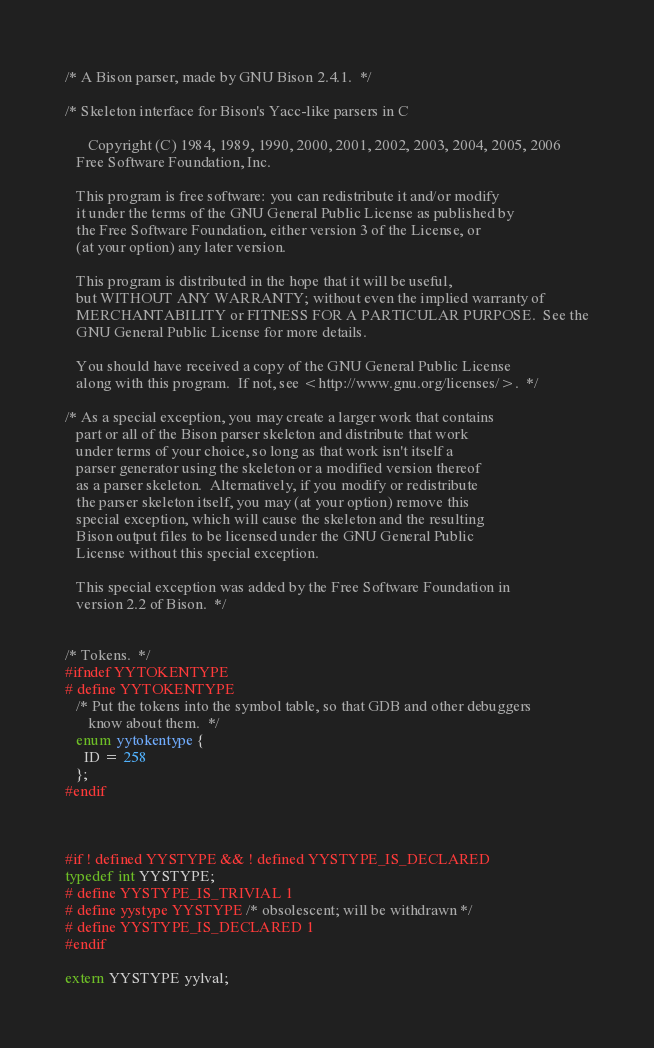Convert code to text. <code><loc_0><loc_0><loc_500><loc_500><_C++_>
/* A Bison parser, made by GNU Bison 2.4.1.  */

/* Skeleton interface for Bison's Yacc-like parsers in C
   
      Copyright (C) 1984, 1989, 1990, 2000, 2001, 2002, 2003, 2004, 2005, 2006
   Free Software Foundation, Inc.
   
   This program is free software: you can redistribute it and/or modify
   it under the terms of the GNU General Public License as published by
   the Free Software Foundation, either version 3 of the License, or
   (at your option) any later version.
   
   This program is distributed in the hope that it will be useful,
   but WITHOUT ANY WARRANTY; without even the implied warranty of
   MERCHANTABILITY or FITNESS FOR A PARTICULAR PURPOSE.  See the
   GNU General Public License for more details.
   
   You should have received a copy of the GNU General Public License
   along with this program.  If not, see <http://www.gnu.org/licenses/>.  */

/* As a special exception, you may create a larger work that contains
   part or all of the Bison parser skeleton and distribute that work
   under terms of your choice, so long as that work isn't itself a
   parser generator using the skeleton or a modified version thereof
   as a parser skeleton.  Alternatively, if you modify or redistribute
   the parser skeleton itself, you may (at your option) remove this
   special exception, which will cause the skeleton and the resulting
   Bison output files to be licensed under the GNU General Public
   License without this special exception.
   
   This special exception was added by the Free Software Foundation in
   version 2.2 of Bison.  */


/* Tokens.  */
#ifndef YYTOKENTYPE
# define YYTOKENTYPE
   /* Put the tokens into the symbol table, so that GDB and other debuggers
      know about them.  */
   enum yytokentype {
     ID = 258
   };
#endif



#if ! defined YYSTYPE && ! defined YYSTYPE_IS_DECLARED
typedef int YYSTYPE;
# define YYSTYPE_IS_TRIVIAL 1
# define yystype YYSTYPE /* obsolescent; will be withdrawn */
# define YYSTYPE_IS_DECLARED 1
#endif

extern YYSTYPE yylval;


</code> 